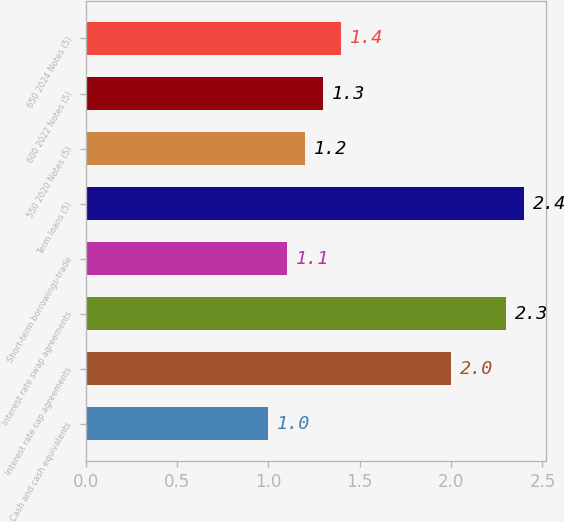<chart> <loc_0><loc_0><loc_500><loc_500><bar_chart><fcel>Cash and cash equivalents<fcel>Interest rate cap agreements<fcel>Interest rate swap agreements<fcel>Short-term borrowings-trade<fcel>Term loans (5)<fcel>550 2020 Notes (5)<fcel>600 2022 Notes (5)<fcel>650 2024 Notes (5)<nl><fcel>1<fcel>2<fcel>2.3<fcel>1.1<fcel>2.4<fcel>1.2<fcel>1.3<fcel>1.4<nl></chart> 